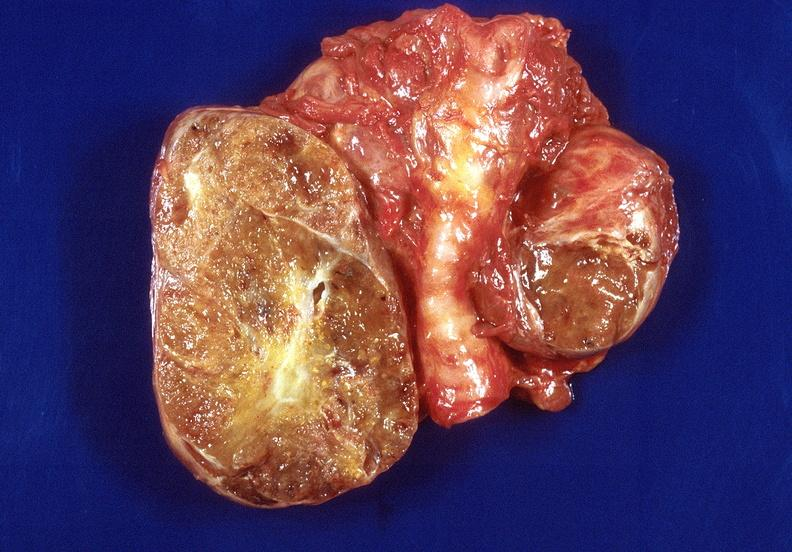where does this belong to?
Answer the question using a single word or phrase. Endocrine system 